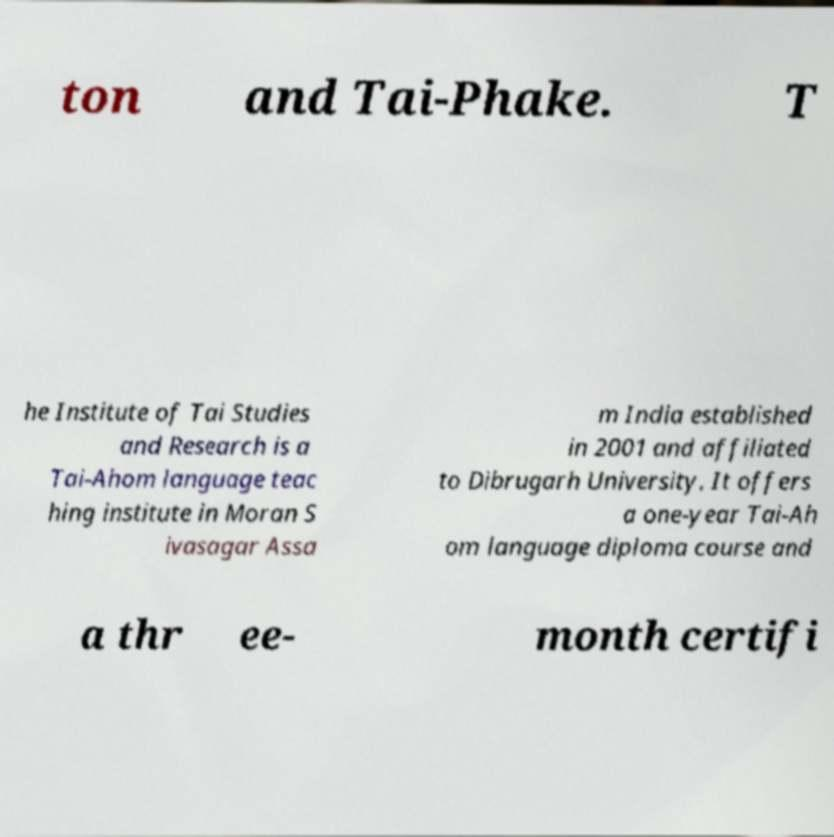There's text embedded in this image that I need extracted. Can you transcribe it verbatim? ton and Tai-Phake. T he Institute of Tai Studies and Research is a Tai-Ahom language teac hing institute in Moran S ivasagar Assa m India established in 2001 and affiliated to Dibrugarh University. It offers a one-year Tai-Ah om language diploma course and a thr ee- month certifi 